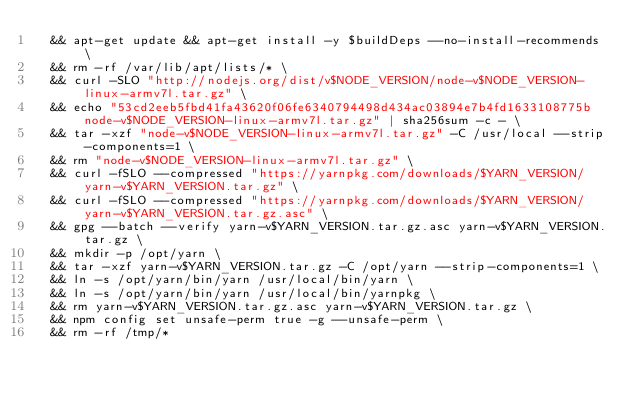<code> <loc_0><loc_0><loc_500><loc_500><_Dockerfile_>	&& apt-get update && apt-get install -y $buildDeps --no-install-recommends \
	&& rm -rf /var/lib/apt/lists/* \
	&& curl -SLO "http://nodejs.org/dist/v$NODE_VERSION/node-v$NODE_VERSION-linux-armv7l.tar.gz" \
	&& echo "53cd2eeb5fbd41fa43620f06fe6340794498d434ac03894e7b4fd1633108775b  node-v$NODE_VERSION-linux-armv7l.tar.gz" | sha256sum -c - \
	&& tar -xzf "node-v$NODE_VERSION-linux-armv7l.tar.gz" -C /usr/local --strip-components=1 \
	&& rm "node-v$NODE_VERSION-linux-armv7l.tar.gz" \
	&& curl -fSLO --compressed "https://yarnpkg.com/downloads/$YARN_VERSION/yarn-v$YARN_VERSION.tar.gz" \
	&& curl -fSLO --compressed "https://yarnpkg.com/downloads/$YARN_VERSION/yarn-v$YARN_VERSION.tar.gz.asc" \
	&& gpg --batch --verify yarn-v$YARN_VERSION.tar.gz.asc yarn-v$YARN_VERSION.tar.gz \
	&& mkdir -p /opt/yarn \
	&& tar -xzf yarn-v$YARN_VERSION.tar.gz -C /opt/yarn --strip-components=1 \
	&& ln -s /opt/yarn/bin/yarn /usr/local/bin/yarn \
	&& ln -s /opt/yarn/bin/yarn /usr/local/bin/yarnpkg \
	&& rm yarn-v$YARN_VERSION.tar.gz.asc yarn-v$YARN_VERSION.tar.gz \
	&& npm config set unsafe-perm true -g --unsafe-perm \
	&& rm -rf /tmp/*
</code> 